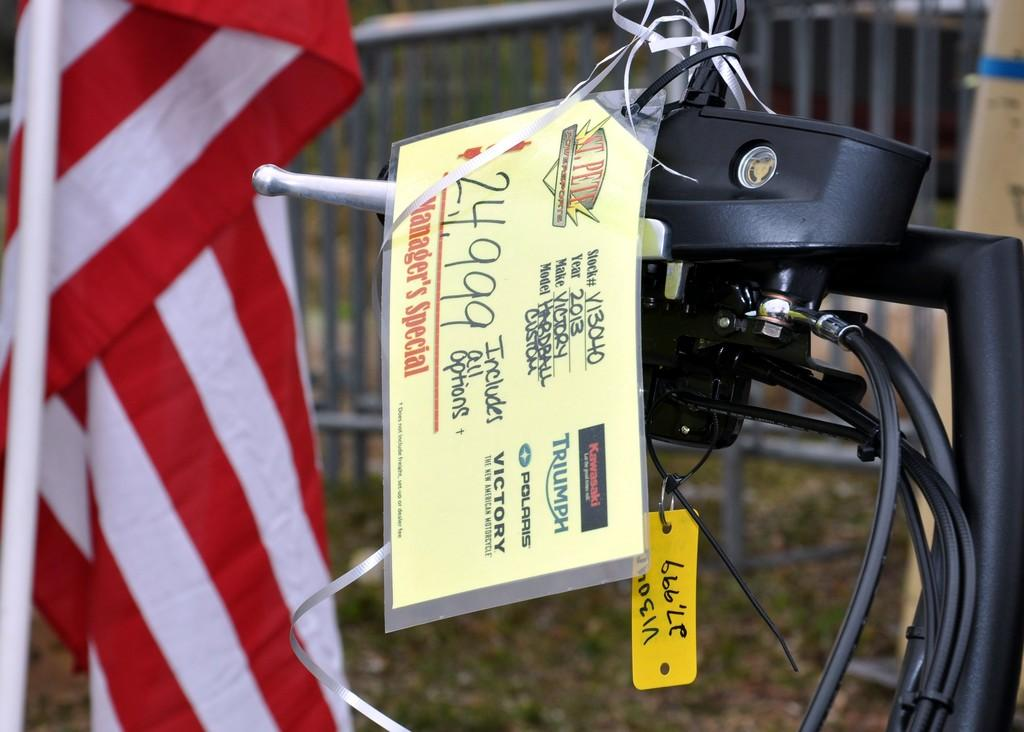What can be seen in the image that represents a symbol or country? There is a flag in the image. What else is present in the image that might be related to the flag? There are wires in the image. What type of equipment or device can be seen in the image? There is a machine in the image. Are there any objects with text or writing in the image? Yes, there are objects with writing in the image. How would you describe the background of the image? The background of the image is blurred. What type of card is being used to operate the railway in the image? There is no railway or card present in the image. What unit of measurement is being used to determine the distance between objects in the image? There is no unit of measurement mentioned or implied in the image. 